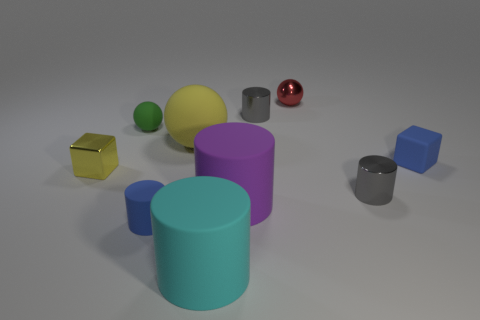What is the shape of the small metallic thing on the left side of the small gray metal thing that is left of the gray shiny cylinder that is to the right of the red metal object?
Offer a terse response. Cube. What color is the small ball that is the same material as the yellow cube?
Offer a terse response. Red. There is a shiny thing to the left of the gray shiny object behind the blue thing behind the small shiny cube; what color is it?
Keep it short and to the point. Yellow. How many cubes are green things or cyan rubber objects?
Provide a succinct answer. 0. There is a thing that is the same color as the large ball; what material is it?
Give a very brief answer. Metal. Do the matte cube and the matte sphere to the left of the large sphere have the same color?
Your answer should be very brief. No. The tiny shiny ball has what color?
Your response must be concise. Red. How many objects are either small gray matte cylinders or blue matte cylinders?
Your answer should be very brief. 1. What material is the red ball that is the same size as the green thing?
Offer a very short reply. Metal. What is the size of the metal cylinder in front of the big yellow matte object?
Your response must be concise. Small. 